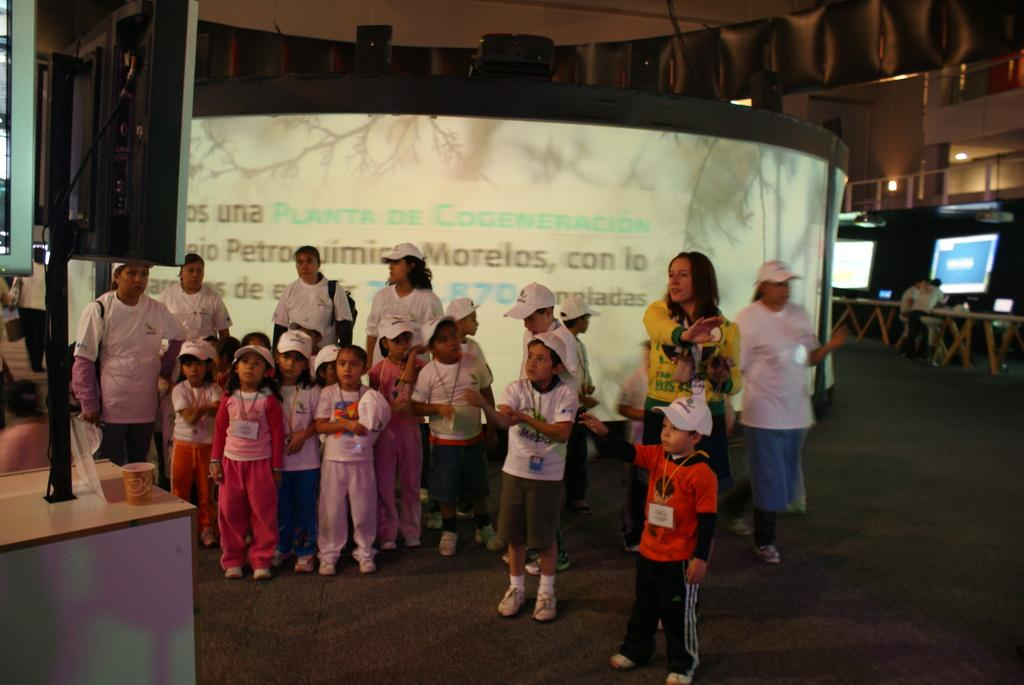How many people are in the image? There is a group of people in the image, but the exact number is not specified. What are the people wearing on their heads? The people are wearing hats. What are the people doing in the image? The people are standing. What can be seen in the background of the image? There are screens, tables, and lights in the background of the image. How many geese are swimming in the background of the image? There are no geese present in the image, and therefore no swimming geese can be observed. 